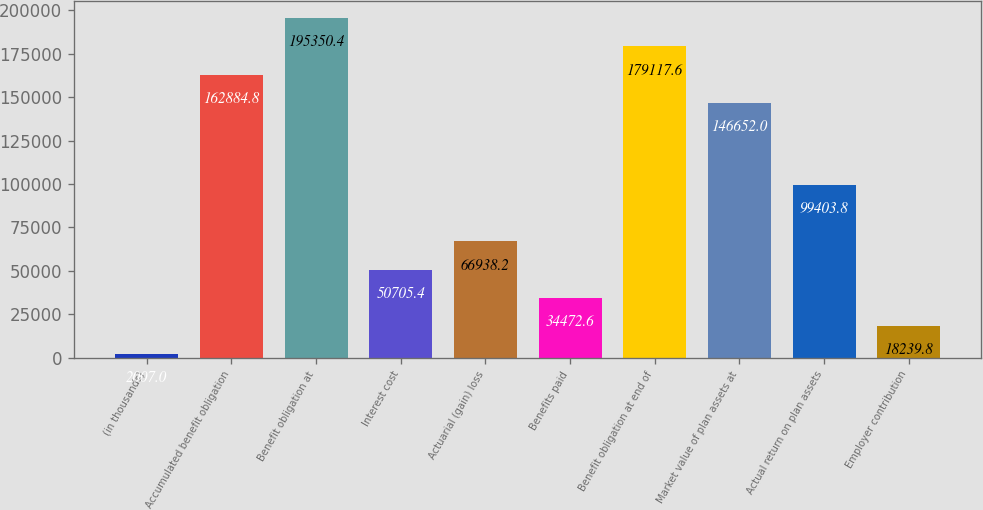<chart> <loc_0><loc_0><loc_500><loc_500><bar_chart><fcel>(in thousands)<fcel>Accumulated benefit obligation<fcel>Benefit obligation at<fcel>Interest cost<fcel>Actuarial (gain) loss<fcel>Benefits paid<fcel>Benefit obligation at end of<fcel>Market value of plan assets at<fcel>Actual return on plan assets<fcel>Employer contribution<nl><fcel>2007<fcel>162885<fcel>195350<fcel>50705.4<fcel>66938.2<fcel>34472.6<fcel>179118<fcel>146652<fcel>99403.8<fcel>18239.8<nl></chart> 